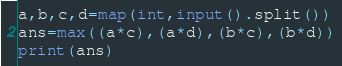Convert code to text. <code><loc_0><loc_0><loc_500><loc_500><_Python_>a,b,c,d=map(int,input().split())
ans=max((a*c),(a*d),(b*c),(b*d))
print(ans)</code> 